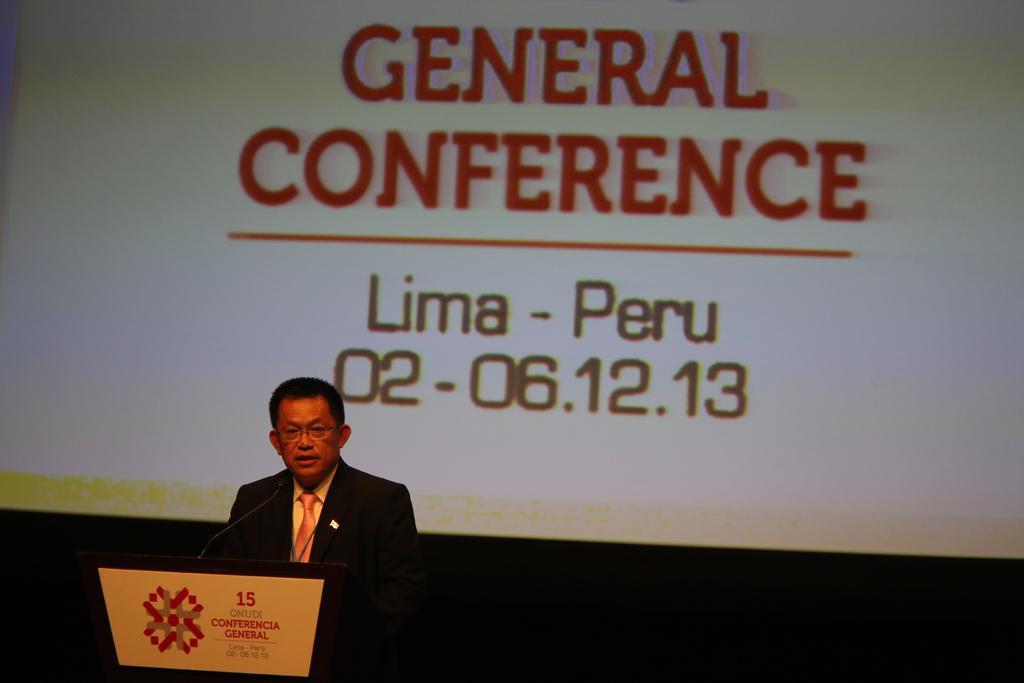Describe this image in one or two sentences. A man is speaking, he wore coat, tie shirt. Behind him it is the projector screen. 